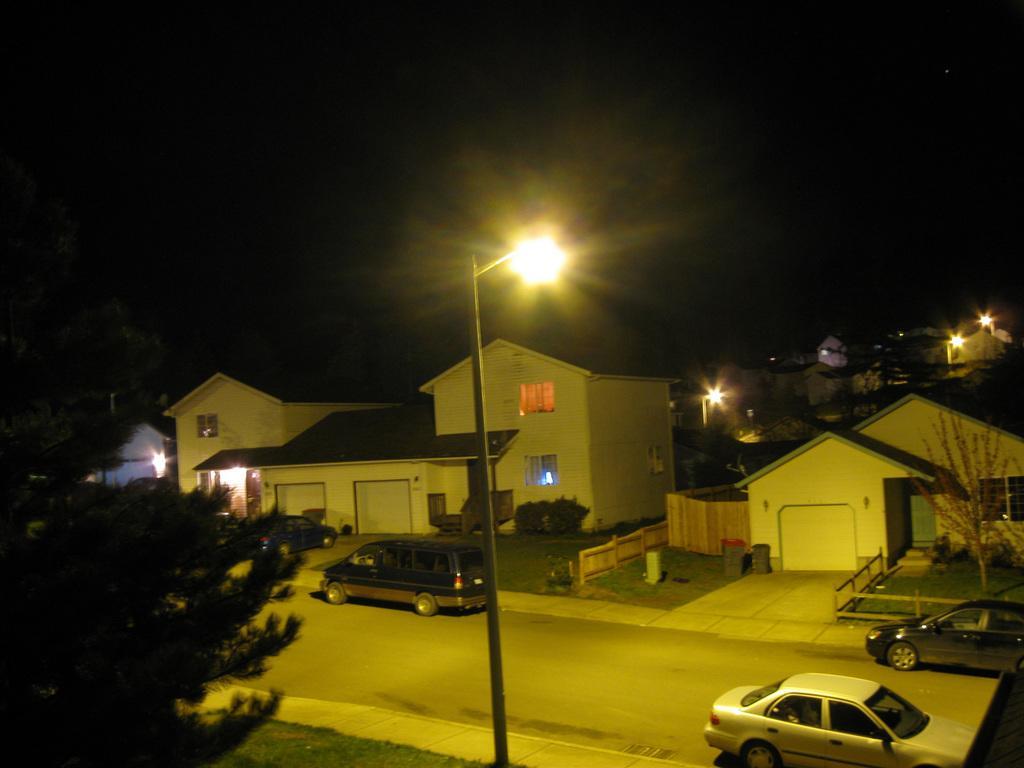Please provide a concise description of this image. In this image I can see in the middle there is a street lamp. On the left side there are trees, at the bottom there are few cars and there are houses. At the top it is the sky in the nighttime. 